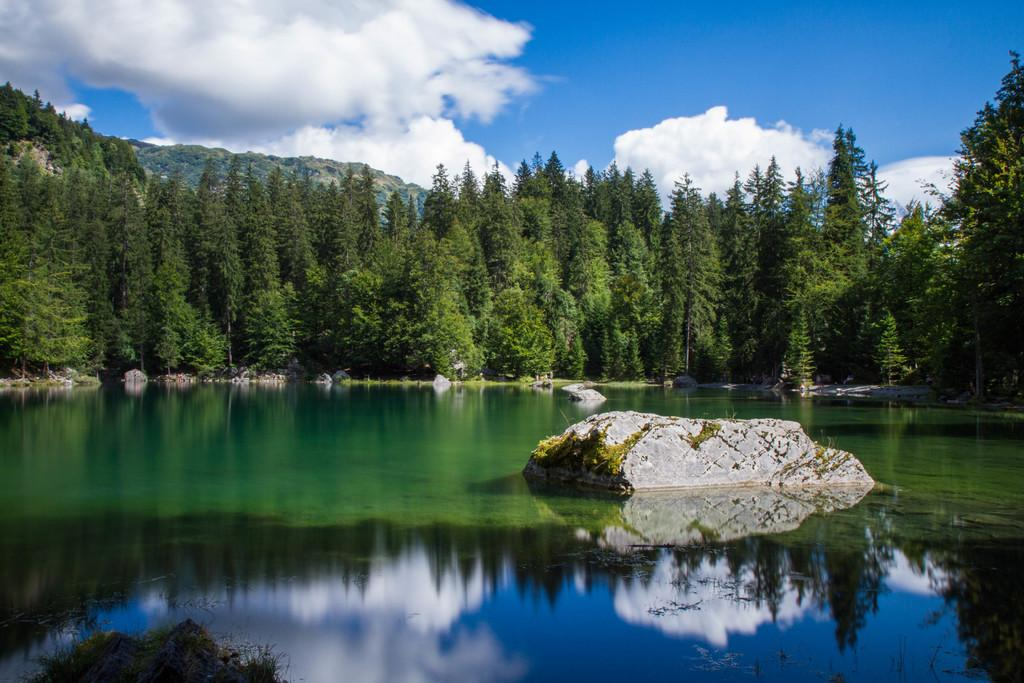What is at the bottom of the image? There is water at the bottom of the image. What is located in the middle of the water? There is a rock in the middle of the water. What can be seen in the background of the image? There are trees and a mountain in the background of the image. What is visible in the sky in the background of the image? There are clouds in the sky in the background of the image. What type of interest is being offered on the voyage depicted in the image? There is no voyage or interest mentioned in the image; it features water, a rock, trees, a mountain, and clouds. 